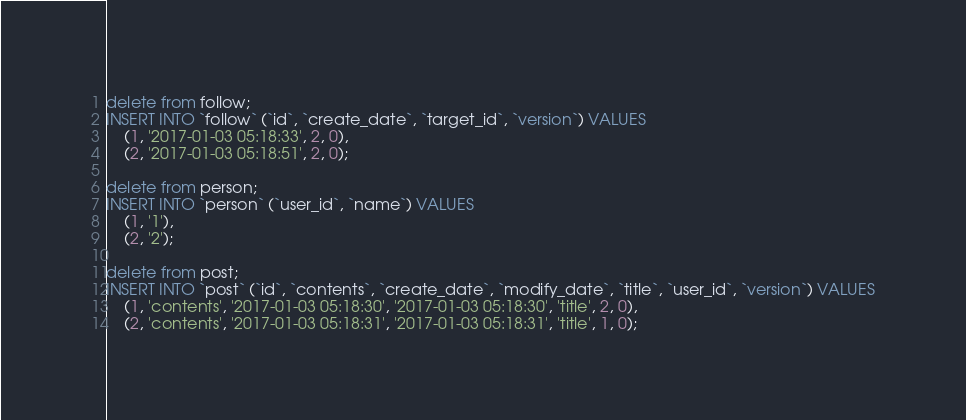Convert code to text. <code><loc_0><loc_0><loc_500><loc_500><_SQL_>delete from follow;
INSERT INTO `follow` (`id`, `create_date`, `target_id`, `version`) VALUES
	(1, '2017-01-03 05:18:33', 2, 0),
	(2, '2017-01-03 05:18:51', 2, 0);

delete from person;
INSERT INTO `person` (`user_id`, `name`) VALUES
	(1, '1'),
	(2, '2');

delete from post;
INSERT INTO `post` (`id`, `contents`, `create_date`, `modify_date`, `title`, `user_id`, `version`) VALUES
	(1, 'contents', '2017-01-03 05:18:30', '2017-01-03 05:18:30', 'title', 2, 0),
	(2, 'contents', '2017-01-03 05:18:31', '2017-01-03 05:18:31', 'title', 1, 0);</code> 